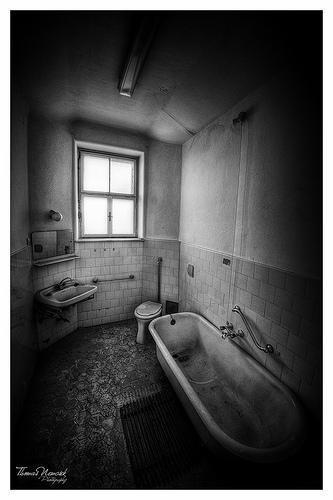How many sinks are there?
Give a very brief answer. 1. 